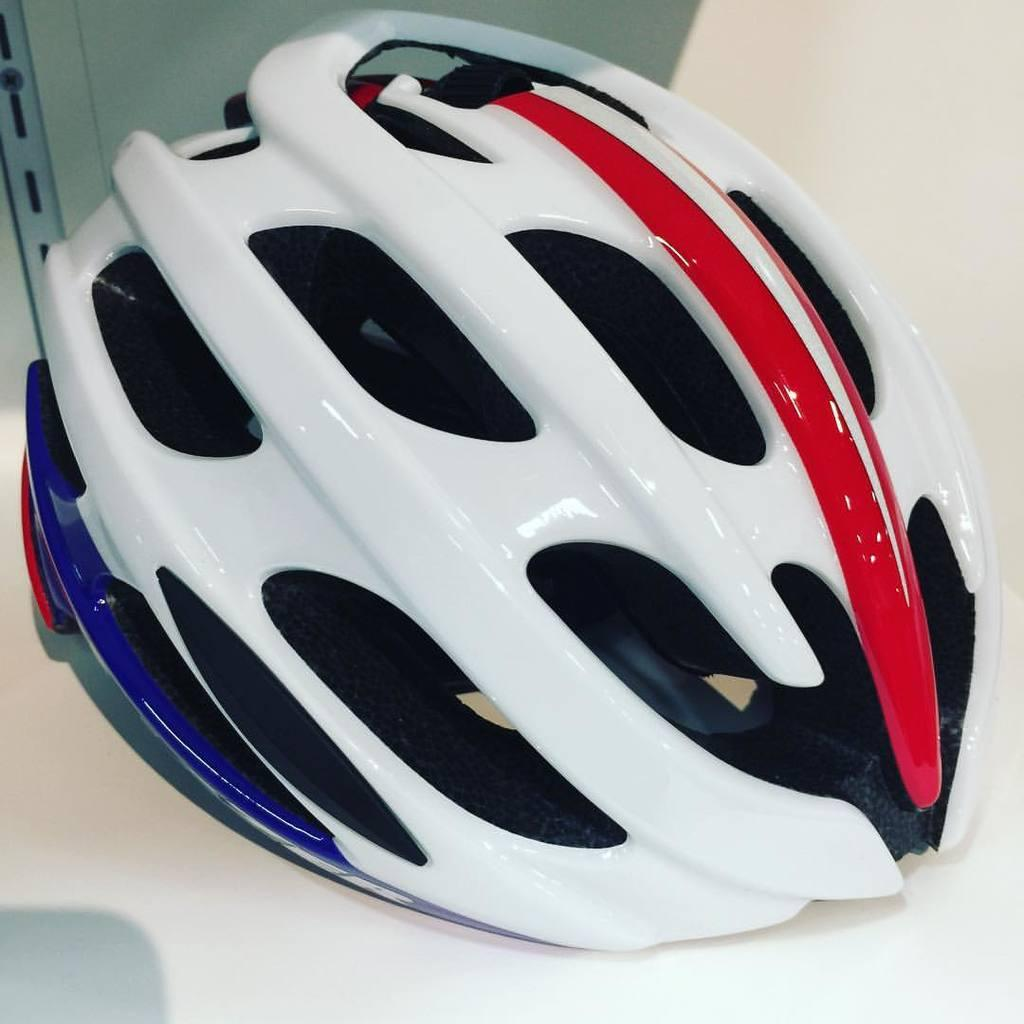What object is on the table in the image? There is a helmet on the table in the image. What is the background of the image? There is a wall visible in the image. What type of stitch is used to create the pattern on the tiger's fur in the image? There is no tiger present in the image, so it is not possible to determine the type of stitch used on its fur. 